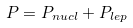<formula> <loc_0><loc_0><loc_500><loc_500>P = P _ { n u c l } + P _ { l e p }</formula> 